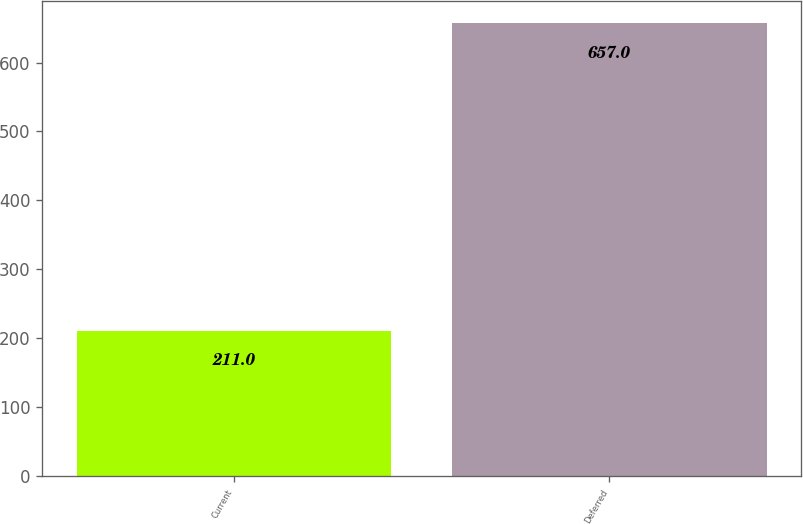Convert chart. <chart><loc_0><loc_0><loc_500><loc_500><bar_chart><fcel>Current<fcel>Deferred<nl><fcel>211<fcel>657<nl></chart> 